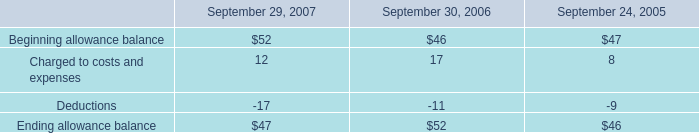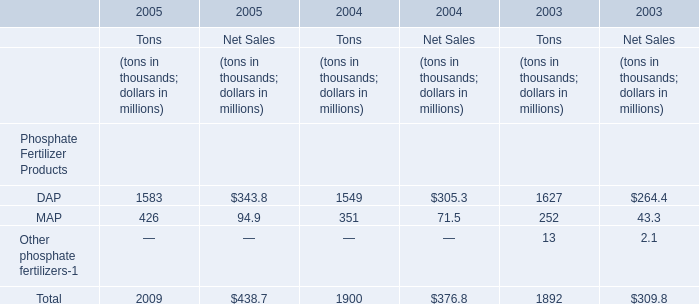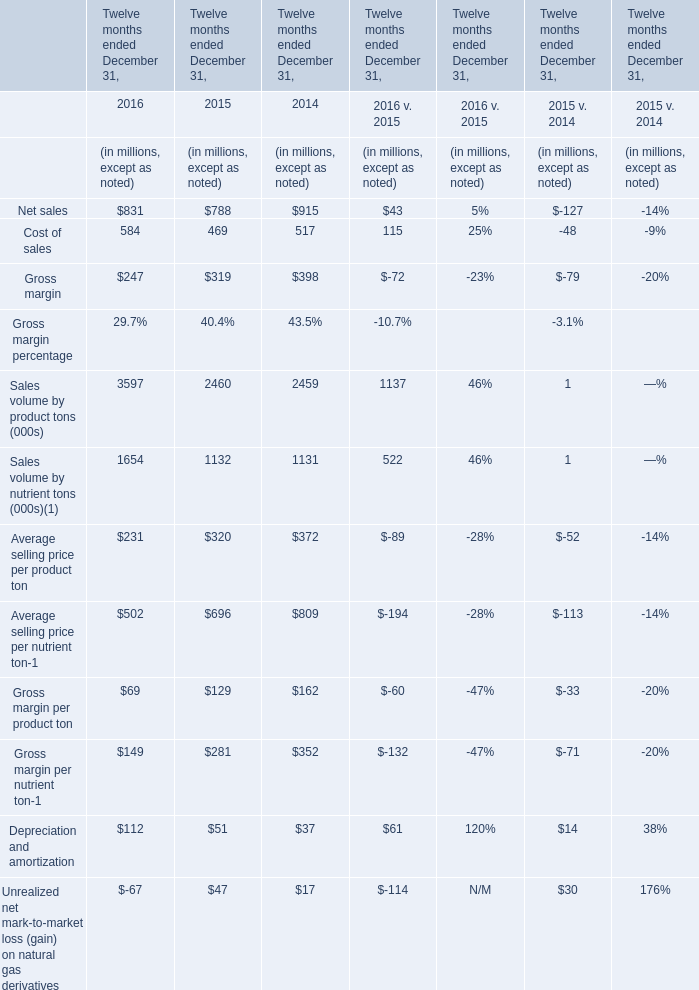What is the ratio of Cost of sales in 2016 to the DAP for Tons in 2005 ? 
Computations: (584 / 1583)
Answer: 0.36892. 